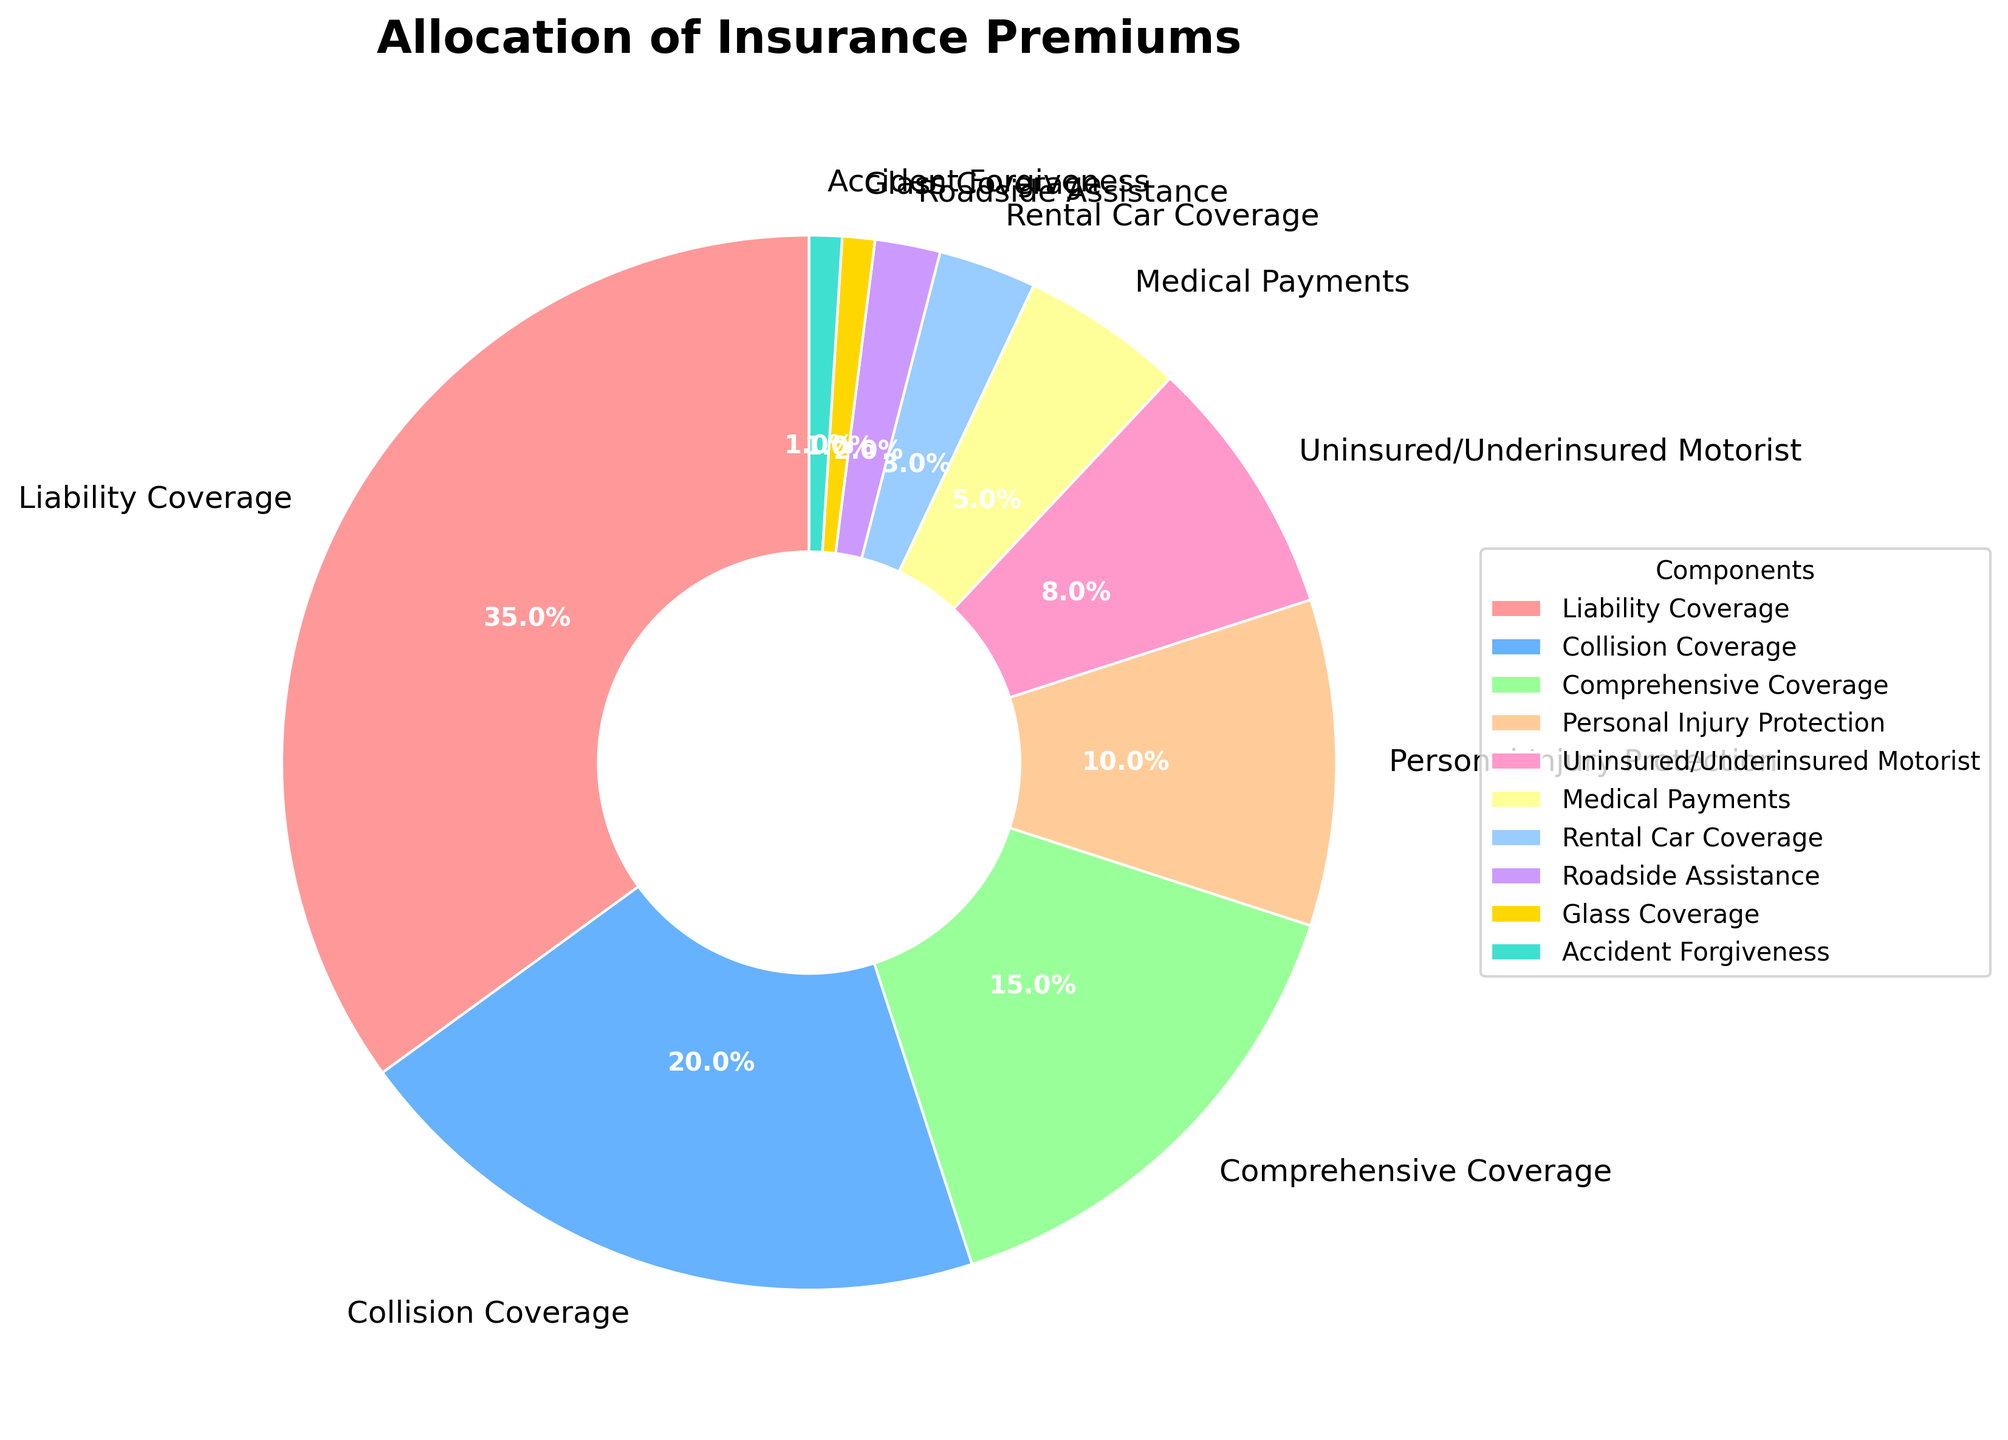What component has the highest percentage allocation in insurance premiums? Identify the largest segment in the pie chart. The "Liability Coverage" segment is the largest.
Answer: Liability Coverage What is the total percentage allocated for Liability Coverage and Collision Coverage combined? Sum the percentages for Liability Coverage (35%) and Collision Coverage (20%). Adding them gives 35% + 20% = 55%.
Answer: 55% Which component has a smaller percentage allocation: Comprehensive Coverage or Medical Payments? Compare the percentages for Comprehensive Coverage (15%) and Medical Payments (5%). 5% < 15%.
Answer: Medical Payments What is the difference in percentage allocation between Personal Injury Protection and Uninsured/Underinsured Motorist? Subtract the percentage for Uninsured/Underinsured Motorist (8%) from Personal Injury Protection (10%). This results in 10% - 8% = 2%.
Answer: 2% Which component has the smallest percentage allocation? Identify the smallest segment in the pie chart. The "Glass Coverage" and "Accident Forgiveness" segments are the smallest, both at 1%.
Answer: Glass Coverage or Accident Forgiveness What is the average percentage allocation for Comprehensive Coverage, Personal Injury Protection, and Medical Payments? Sum the percentages for the three components: Comprehensive Coverage (15%), Personal Injury Protection (10%), and Medical Payments (5%). The total is 15% + 10% + 5% = 30%. Divide by 3 to get the average: 30% / 3 = 10%.
Answer: 10% Which components collectively make up more than half (50%) of the total allocation? List components and accumulate their percentages until surpassing 50%. Liability Coverage (35%) + Collision Coverage (20%) total 55%, which exceeds 50%.
Answer: Liability Coverage and Collision Coverage What percentage of the total allocation is for Roadside Assistance, Rental Car Coverage, and Glass Coverage combined? Sum the percentages for Roadside Assistance (2%), Rental Car Coverage (3%), and Glass Coverage (1%). The total is 2% + 3% + 1% = 6%.
Answer: 6% 